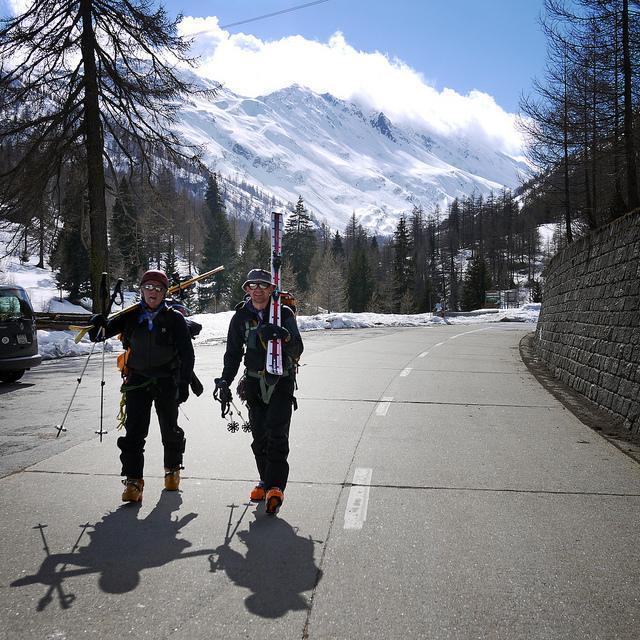How many people can you see?
Give a very brief answer. 2. 